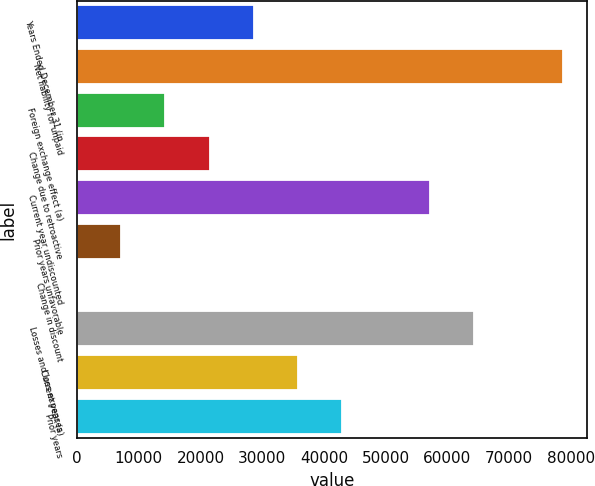Convert chart to OTSL. <chart><loc_0><loc_0><loc_500><loc_500><bar_chart><fcel>Years Ended December 31 (in<fcel>Net liability for unpaid<fcel>Foreign exchange effect (a)<fcel>Change due to retroactive<fcel>Current year undiscounted<fcel>Prior years unfavorable<fcel>Change in discount<fcel>Losses and loss expenses<fcel>Current year (a)<fcel>Prior years<nl><fcel>28623.2<fcel>78654.3<fcel>14328.6<fcel>21475.9<fcel>57212.4<fcel>7181.3<fcel>34<fcel>64359.7<fcel>35770.5<fcel>42917.8<nl></chart> 